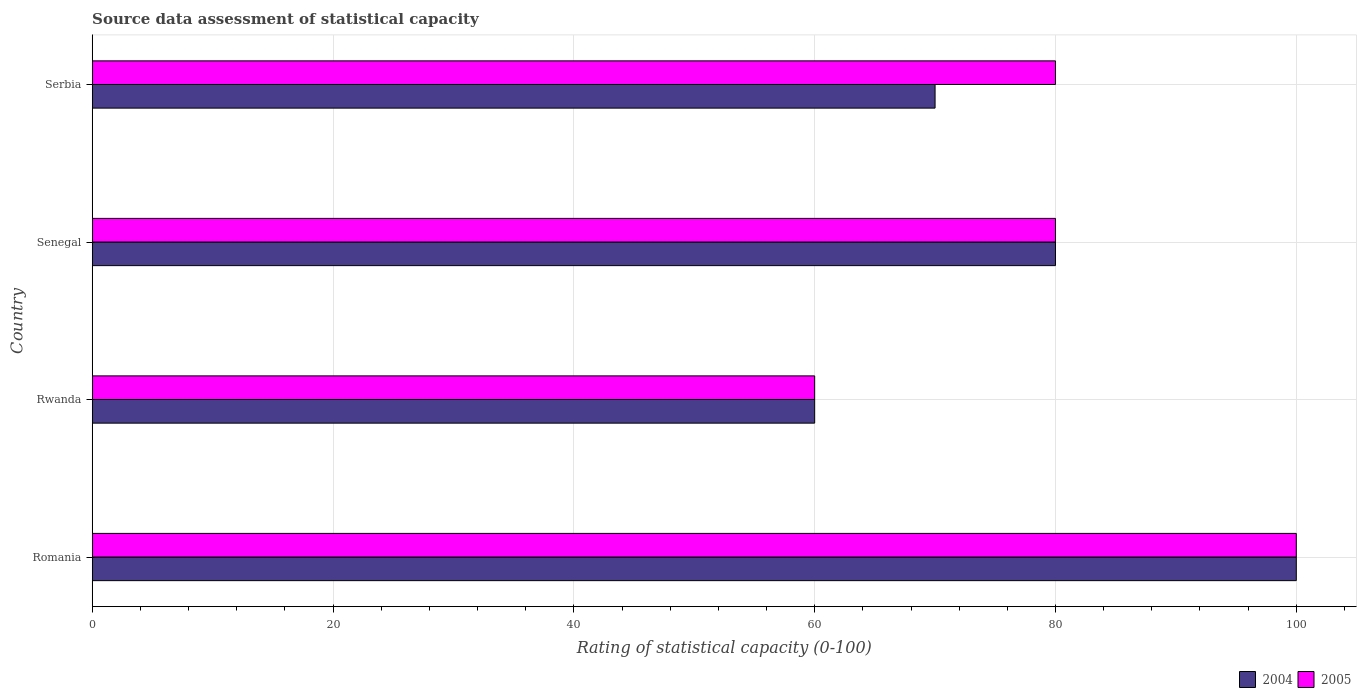How many different coloured bars are there?
Keep it short and to the point. 2. Are the number of bars on each tick of the Y-axis equal?
Your response must be concise. Yes. How many bars are there on the 3rd tick from the bottom?
Give a very brief answer. 2. What is the label of the 2nd group of bars from the top?
Make the answer very short. Senegal. Across all countries, what is the maximum rating of statistical capacity in 2004?
Your response must be concise. 100. Across all countries, what is the minimum rating of statistical capacity in 2005?
Ensure brevity in your answer.  60. In which country was the rating of statistical capacity in 2004 maximum?
Your answer should be compact. Romania. In which country was the rating of statistical capacity in 2005 minimum?
Your answer should be very brief. Rwanda. What is the total rating of statistical capacity in 2004 in the graph?
Your answer should be very brief. 310. What is the average rating of statistical capacity in 2005 per country?
Ensure brevity in your answer.  80. What is the difference between the rating of statistical capacity in 2004 and rating of statistical capacity in 2005 in Rwanda?
Provide a succinct answer. 0. In how many countries, is the rating of statistical capacity in 2005 greater than 36 ?
Offer a very short reply. 4. What is the ratio of the rating of statistical capacity in 2004 in Rwanda to that in Serbia?
Your response must be concise. 0.86. Is the rating of statistical capacity in 2004 in Romania less than that in Senegal?
Provide a succinct answer. No. Is the difference between the rating of statistical capacity in 2004 in Romania and Rwanda greater than the difference between the rating of statistical capacity in 2005 in Romania and Rwanda?
Your answer should be compact. No. What is the difference between the highest and the second highest rating of statistical capacity in 2005?
Your answer should be very brief. 20. Is the sum of the rating of statistical capacity in 2005 in Romania and Rwanda greater than the maximum rating of statistical capacity in 2004 across all countries?
Your answer should be very brief. Yes. What does the 2nd bar from the top in Rwanda represents?
Your answer should be very brief. 2004. What does the 1st bar from the bottom in Serbia represents?
Make the answer very short. 2004. How many bars are there?
Your answer should be very brief. 8. How many countries are there in the graph?
Ensure brevity in your answer.  4. What is the difference between two consecutive major ticks on the X-axis?
Offer a terse response. 20. Are the values on the major ticks of X-axis written in scientific E-notation?
Provide a succinct answer. No. How many legend labels are there?
Your answer should be very brief. 2. What is the title of the graph?
Your answer should be very brief. Source data assessment of statistical capacity. What is the label or title of the X-axis?
Offer a terse response. Rating of statistical capacity (0-100). What is the label or title of the Y-axis?
Offer a very short reply. Country. What is the Rating of statistical capacity (0-100) of 2004 in Romania?
Your answer should be compact. 100. What is the Rating of statistical capacity (0-100) in 2005 in Romania?
Your answer should be very brief. 100. What is the Rating of statistical capacity (0-100) of 2004 in Rwanda?
Offer a very short reply. 60. What is the Rating of statistical capacity (0-100) in 2005 in Senegal?
Make the answer very short. 80. What is the Rating of statistical capacity (0-100) in 2005 in Serbia?
Make the answer very short. 80. Across all countries, what is the minimum Rating of statistical capacity (0-100) of 2004?
Your response must be concise. 60. What is the total Rating of statistical capacity (0-100) in 2004 in the graph?
Make the answer very short. 310. What is the total Rating of statistical capacity (0-100) of 2005 in the graph?
Provide a short and direct response. 320. What is the difference between the Rating of statistical capacity (0-100) of 2004 in Romania and that in Rwanda?
Make the answer very short. 40. What is the difference between the Rating of statistical capacity (0-100) of 2005 in Romania and that in Rwanda?
Your answer should be compact. 40. What is the difference between the Rating of statistical capacity (0-100) in 2004 in Rwanda and that in Senegal?
Your answer should be compact. -20. What is the difference between the Rating of statistical capacity (0-100) of 2005 in Rwanda and that in Senegal?
Give a very brief answer. -20. What is the difference between the Rating of statistical capacity (0-100) of 2005 in Rwanda and that in Serbia?
Your answer should be compact. -20. What is the difference between the Rating of statistical capacity (0-100) in 2004 in Senegal and that in Serbia?
Offer a terse response. 10. What is the difference between the Rating of statistical capacity (0-100) in 2005 in Senegal and that in Serbia?
Your answer should be compact. 0. What is the difference between the Rating of statistical capacity (0-100) of 2004 in Romania and the Rating of statistical capacity (0-100) of 2005 in Senegal?
Offer a terse response. 20. What is the difference between the Rating of statistical capacity (0-100) in 2004 in Rwanda and the Rating of statistical capacity (0-100) in 2005 in Serbia?
Offer a very short reply. -20. What is the difference between the Rating of statistical capacity (0-100) of 2004 in Senegal and the Rating of statistical capacity (0-100) of 2005 in Serbia?
Make the answer very short. 0. What is the average Rating of statistical capacity (0-100) of 2004 per country?
Ensure brevity in your answer.  77.5. What is the difference between the Rating of statistical capacity (0-100) of 2004 and Rating of statistical capacity (0-100) of 2005 in Romania?
Your answer should be very brief. 0. What is the difference between the Rating of statistical capacity (0-100) of 2004 and Rating of statistical capacity (0-100) of 2005 in Rwanda?
Your response must be concise. 0. What is the ratio of the Rating of statistical capacity (0-100) in 2004 in Romania to that in Rwanda?
Your answer should be compact. 1.67. What is the ratio of the Rating of statistical capacity (0-100) in 2005 in Romania to that in Senegal?
Keep it short and to the point. 1.25. What is the ratio of the Rating of statistical capacity (0-100) in 2004 in Romania to that in Serbia?
Your answer should be very brief. 1.43. What is the ratio of the Rating of statistical capacity (0-100) in 2005 in Rwanda to that in Senegal?
Your answer should be compact. 0.75. What is the ratio of the Rating of statistical capacity (0-100) in 2005 in Rwanda to that in Serbia?
Offer a terse response. 0.75. What is the difference between the highest and the lowest Rating of statistical capacity (0-100) in 2004?
Your answer should be compact. 40. 